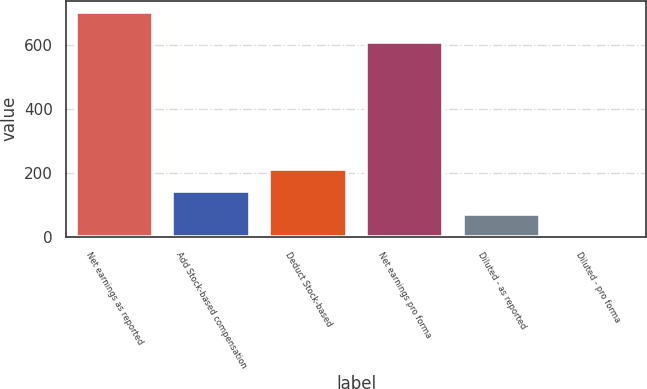Convert chart to OTSL. <chart><loc_0><loc_0><loc_500><loc_500><bar_chart><fcel>Net earnings as reported<fcel>Add Stock-based compensation<fcel>Deduct Stock-based<fcel>Net earnings pro forma<fcel>Diluted - as reported<fcel>Diluted - pro forma<nl><fcel>705<fcel>142<fcel>212.38<fcel>609<fcel>71.62<fcel>1.25<nl></chart> 